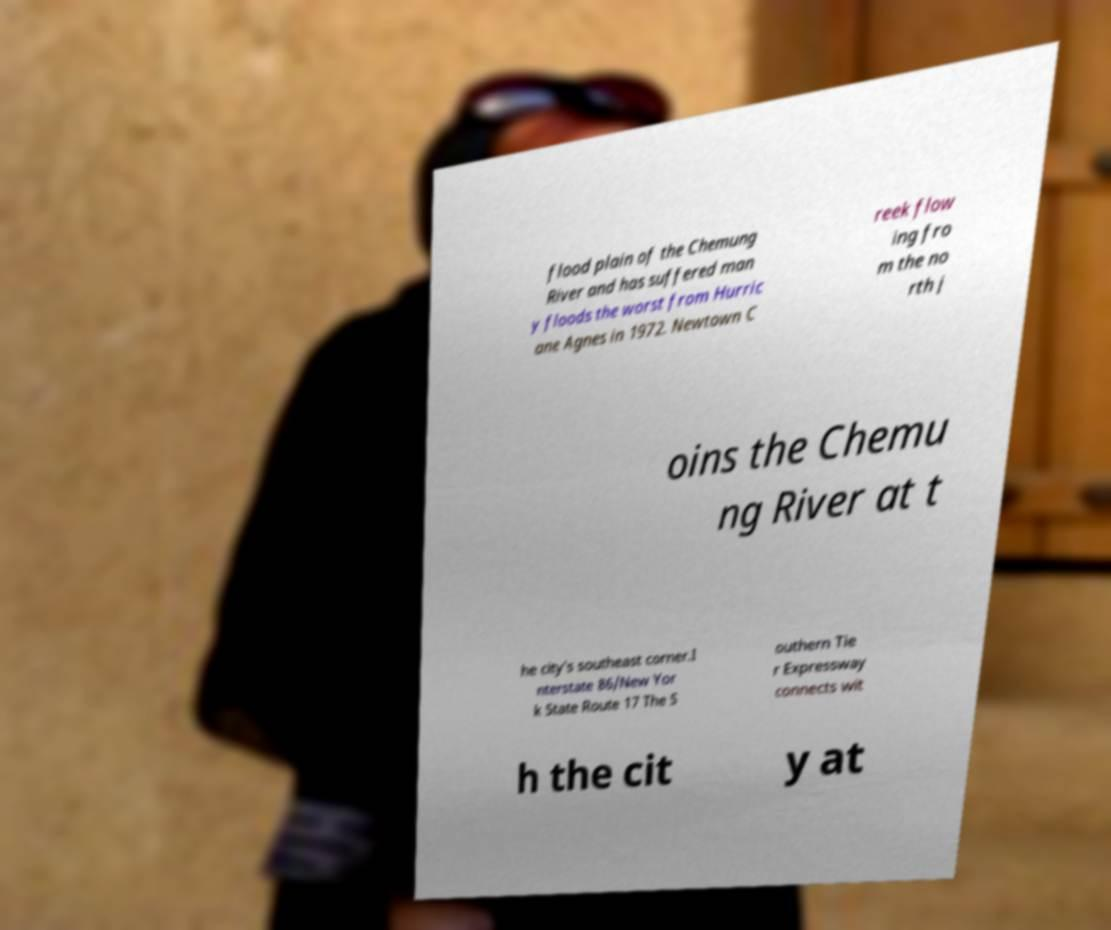For documentation purposes, I need the text within this image transcribed. Could you provide that? flood plain of the Chemung River and has suffered man y floods the worst from Hurric ane Agnes in 1972. Newtown C reek flow ing fro m the no rth j oins the Chemu ng River at t he city's southeast corner.I nterstate 86/New Yor k State Route 17 The S outhern Tie r Expressway connects wit h the cit y at 